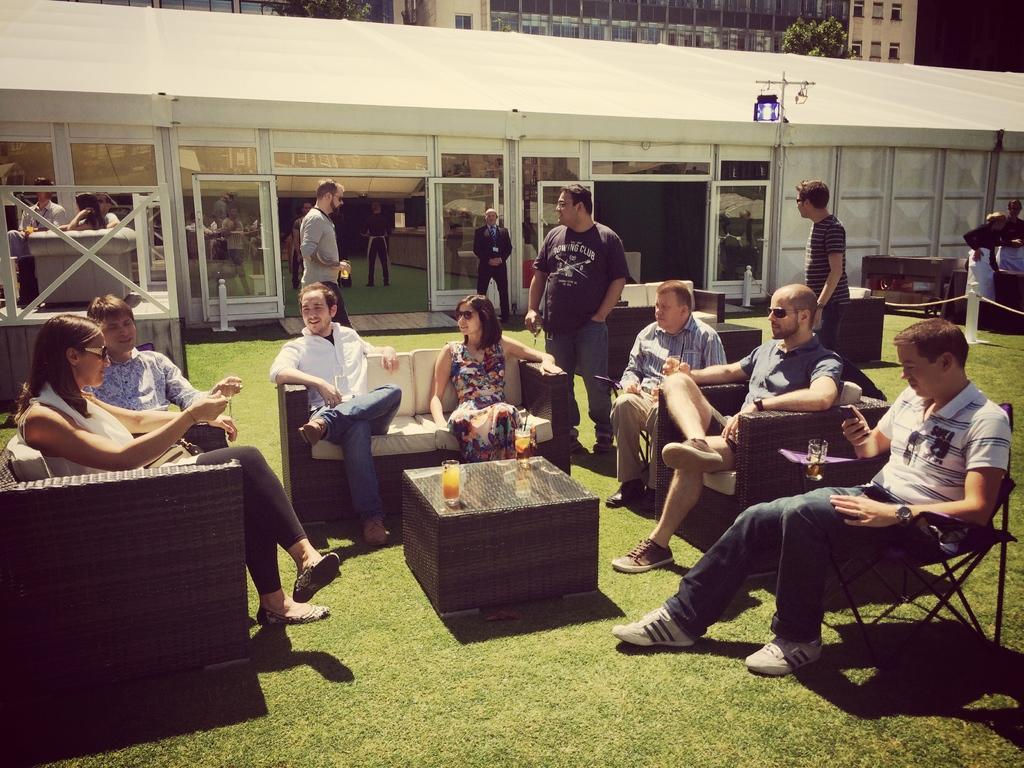In one or two sentences, can you explain what this image depicts? In this picture, we see many people sitting on sofa. In front of them, we see a table on which glass containing cool drink is placed. Behind them, we see two people walking in the garden and behind that, we see a building which is white in color. 